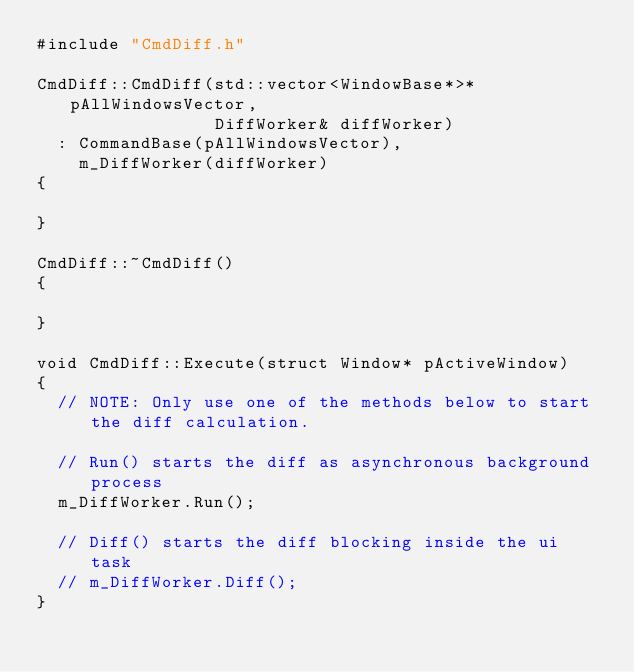<code> <loc_0><loc_0><loc_500><loc_500><_C++_>#include "CmdDiff.h"

CmdDiff::CmdDiff(std::vector<WindowBase*>* pAllWindowsVector,
                 DiffWorker& diffWorker)
  : CommandBase(pAllWindowsVector),
    m_DiffWorker(diffWorker)
{

}

CmdDiff::~CmdDiff()
{

}

void CmdDiff::Execute(struct Window* pActiveWindow)
{
  // NOTE: Only use one of the methods below to start the diff calculation.

  // Run() starts the diff as asynchronous background process
  m_DiffWorker.Run();

  // Diff() starts the diff blocking inside the ui task
  // m_DiffWorker.Diff();
}
</code> 